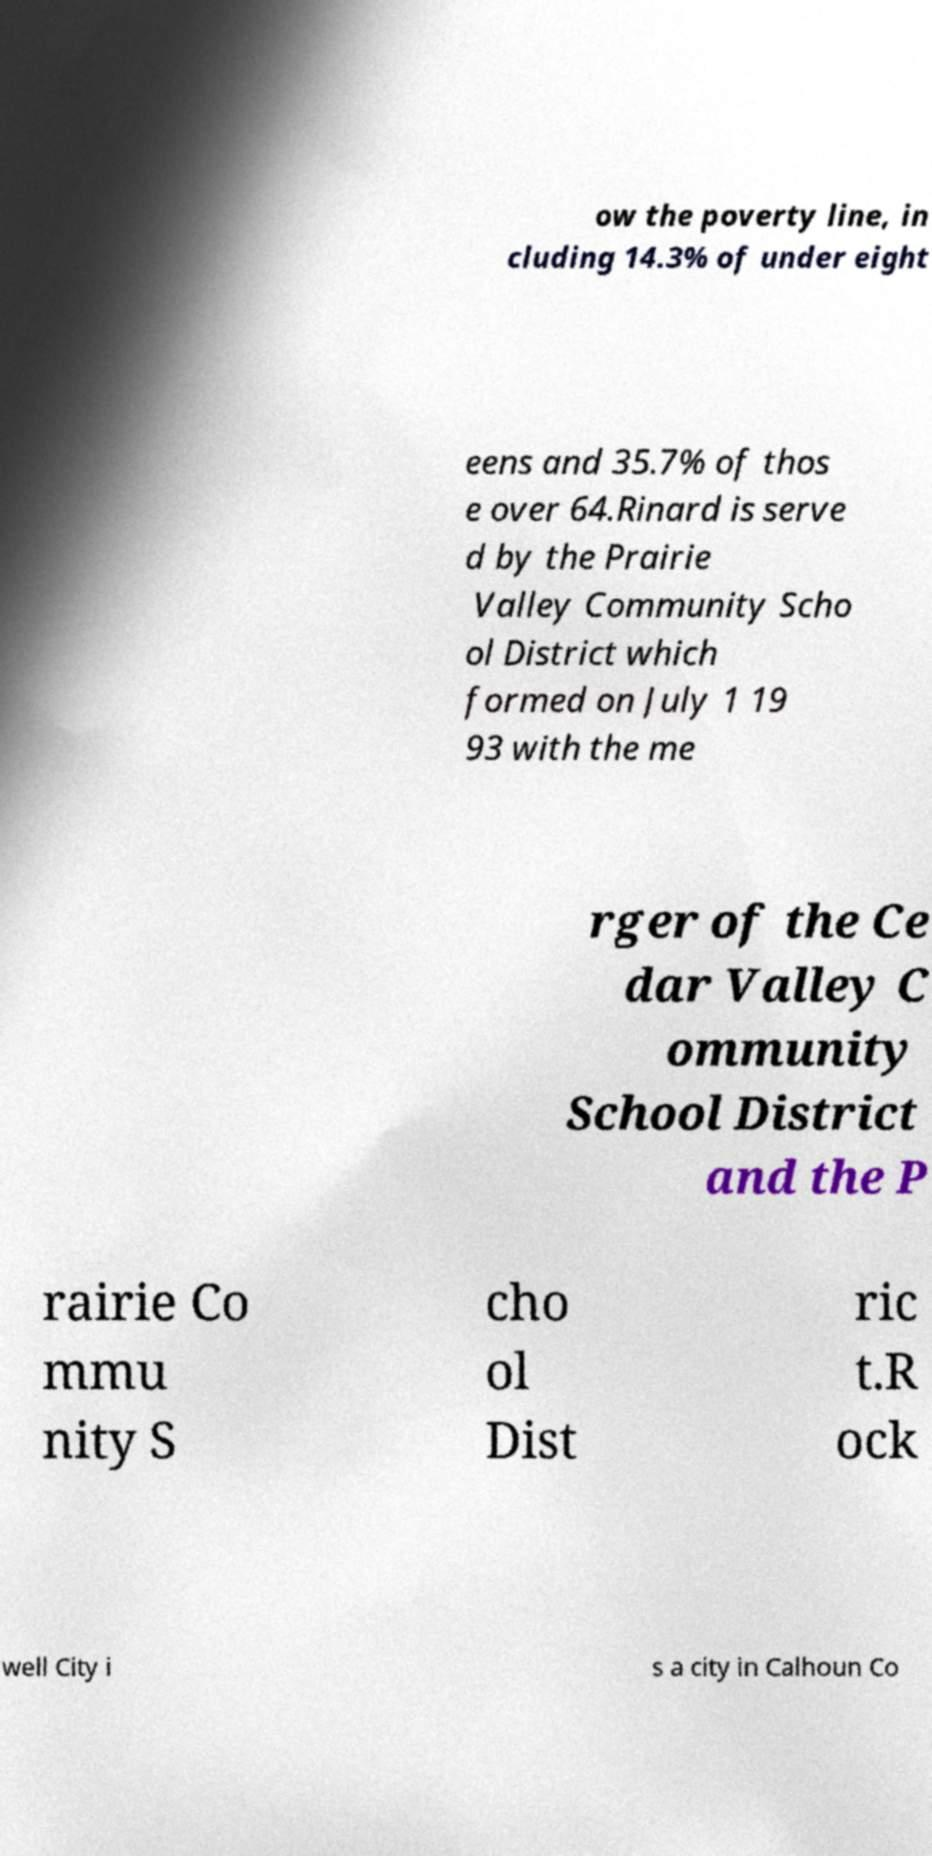Please identify and transcribe the text found in this image. ow the poverty line, in cluding 14.3% of under eight eens and 35.7% of thos e over 64.Rinard is serve d by the Prairie Valley Community Scho ol District which formed on July 1 19 93 with the me rger of the Ce dar Valley C ommunity School District and the P rairie Co mmu nity S cho ol Dist ric t.R ock well City i s a city in Calhoun Co 